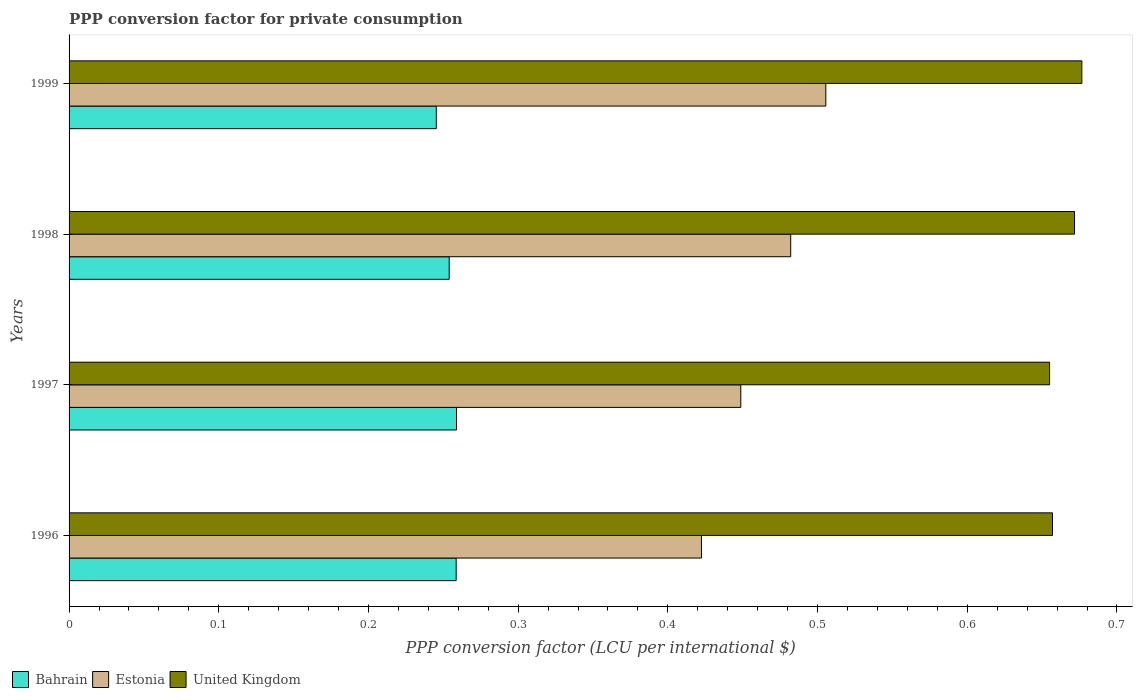How many different coloured bars are there?
Provide a succinct answer. 3. How many groups of bars are there?
Your response must be concise. 4. Are the number of bars per tick equal to the number of legend labels?
Make the answer very short. Yes. Are the number of bars on each tick of the Y-axis equal?
Offer a terse response. Yes. How many bars are there on the 2nd tick from the bottom?
Keep it short and to the point. 3. What is the PPP conversion factor for private consumption in United Kingdom in 1998?
Ensure brevity in your answer.  0.67. Across all years, what is the maximum PPP conversion factor for private consumption in United Kingdom?
Keep it short and to the point. 0.68. Across all years, what is the minimum PPP conversion factor for private consumption in Bahrain?
Provide a succinct answer. 0.25. In which year was the PPP conversion factor for private consumption in United Kingdom minimum?
Make the answer very short. 1997. What is the total PPP conversion factor for private consumption in United Kingdom in the graph?
Provide a short and direct response. 2.66. What is the difference between the PPP conversion factor for private consumption in United Kingdom in 1996 and that in 1999?
Make the answer very short. -0.02. What is the difference between the PPP conversion factor for private consumption in Estonia in 1996 and the PPP conversion factor for private consumption in United Kingdom in 1998?
Your response must be concise. -0.25. What is the average PPP conversion factor for private consumption in Estonia per year?
Your answer should be very brief. 0.46. In the year 1997, what is the difference between the PPP conversion factor for private consumption in Estonia and PPP conversion factor for private consumption in United Kingdom?
Your response must be concise. -0.21. In how many years, is the PPP conversion factor for private consumption in Estonia greater than 0.6000000000000001 LCU?
Offer a terse response. 0. What is the ratio of the PPP conversion factor for private consumption in Estonia in 1996 to that in 1999?
Your answer should be very brief. 0.84. Is the PPP conversion factor for private consumption in Bahrain in 1998 less than that in 1999?
Provide a short and direct response. No. What is the difference between the highest and the second highest PPP conversion factor for private consumption in Bahrain?
Your answer should be compact. 0. What is the difference between the highest and the lowest PPP conversion factor for private consumption in United Kingdom?
Your answer should be compact. 0.02. In how many years, is the PPP conversion factor for private consumption in Bahrain greater than the average PPP conversion factor for private consumption in Bahrain taken over all years?
Provide a succinct answer. 2. What does the 2nd bar from the top in 1996 represents?
Offer a terse response. Estonia. What does the 3rd bar from the bottom in 1999 represents?
Provide a succinct answer. United Kingdom. Is it the case that in every year, the sum of the PPP conversion factor for private consumption in Bahrain and PPP conversion factor for private consumption in Estonia is greater than the PPP conversion factor for private consumption in United Kingdom?
Offer a very short reply. Yes. How many bars are there?
Give a very brief answer. 12. How many years are there in the graph?
Provide a succinct answer. 4. What is the difference between two consecutive major ticks on the X-axis?
Your answer should be very brief. 0.1. Are the values on the major ticks of X-axis written in scientific E-notation?
Ensure brevity in your answer.  No. Does the graph contain any zero values?
Make the answer very short. No. Where does the legend appear in the graph?
Give a very brief answer. Bottom left. How are the legend labels stacked?
Keep it short and to the point. Horizontal. What is the title of the graph?
Your response must be concise. PPP conversion factor for private consumption. What is the label or title of the X-axis?
Your answer should be compact. PPP conversion factor (LCU per international $). What is the PPP conversion factor (LCU per international $) of Bahrain in 1996?
Your answer should be very brief. 0.26. What is the PPP conversion factor (LCU per international $) of Estonia in 1996?
Your answer should be compact. 0.42. What is the PPP conversion factor (LCU per international $) of United Kingdom in 1996?
Offer a terse response. 0.66. What is the PPP conversion factor (LCU per international $) of Bahrain in 1997?
Offer a terse response. 0.26. What is the PPP conversion factor (LCU per international $) in Estonia in 1997?
Keep it short and to the point. 0.45. What is the PPP conversion factor (LCU per international $) in United Kingdom in 1997?
Make the answer very short. 0.65. What is the PPP conversion factor (LCU per international $) of Bahrain in 1998?
Your answer should be very brief. 0.25. What is the PPP conversion factor (LCU per international $) in Estonia in 1998?
Keep it short and to the point. 0.48. What is the PPP conversion factor (LCU per international $) of United Kingdom in 1998?
Provide a succinct answer. 0.67. What is the PPP conversion factor (LCU per international $) of Bahrain in 1999?
Make the answer very short. 0.25. What is the PPP conversion factor (LCU per international $) of Estonia in 1999?
Provide a short and direct response. 0.51. What is the PPP conversion factor (LCU per international $) of United Kingdom in 1999?
Provide a short and direct response. 0.68. Across all years, what is the maximum PPP conversion factor (LCU per international $) in Bahrain?
Keep it short and to the point. 0.26. Across all years, what is the maximum PPP conversion factor (LCU per international $) of Estonia?
Your answer should be very brief. 0.51. Across all years, what is the maximum PPP conversion factor (LCU per international $) in United Kingdom?
Offer a terse response. 0.68. Across all years, what is the minimum PPP conversion factor (LCU per international $) of Bahrain?
Keep it short and to the point. 0.25. Across all years, what is the minimum PPP conversion factor (LCU per international $) in Estonia?
Provide a succinct answer. 0.42. Across all years, what is the minimum PPP conversion factor (LCU per international $) in United Kingdom?
Provide a short and direct response. 0.65. What is the total PPP conversion factor (LCU per international $) in Bahrain in the graph?
Offer a terse response. 1.02. What is the total PPP conversion factor (LCU per international $) of Estonia in the graph?
Your answer should be compact. 1.86. What is the total PPP conversion factor (LCU per international $) of United Kingdom in the graph?
Provide a succinct answer. 2.66. What is the difference between the PPP conversion factor (LCU per international $) of Bahrain in 1996 and that in 1997?
Your response must be concise. -0. What is the difference between the PPP conversion factor (LCU per international $) of Estonia in 1996 and that in 1997?
Give a very brief answer. -0.03. What is the difference between the PPP conversion factor (LCU per international $) of United Kingdom in 1996 and that in 1997?
Provide a short and direct response. 0. What is the difference between the PPP conversion factor (LCU per international $) in Bahrain in 1996 and that in 1998?
Make the answer very short. 0. What is the difference between the PPP conversion factor (LCU per international $) of Estonia in 1996 and that in 1998?
Ensure brevity in your answer.  -0.06. What is the difference between the PPP conversion factor (LCU per international $) in United Kingdom in 1996 and that in 1998?
Offer a terse response. -0.01. What is the difference between the PPP conversion factor (LCU per international $) in Bahrain in 1996 and that in 1999?
Keep it short and to the point. 0.01. What is the difference between the PPP conversion factor (LCU per international $) in Estonia in 1996 and that in 1999?
Provide a succinct answer. -0.08. What is the difference between the PPP conversion factor (LCU per international $) in United Kingdom in 1996 and that in 1999?
Ensure brevity in your answer.  -0.02. What is the difference between the PPP conversion factor (LCU per international $) in Bahrain in 1997 and that in 1998?
Offer a terse response. 0. What is the difference between the PPP conversion factor (LCU per international $) of Estonia in 1997 and that in 1998?
Your answer should be compact. -0.03. What is the difference between the PPP conversion factor (LCU per international $) in United Kingdom in 1997 and that in 1998?
Give a very brief answer. -0.02. What is the difference between the PPP conversion factor (LCU per international $) in Bahrain in 1997 and that in 1999?
Make the answer very short. 0.01. What is the difference between the PPP conversion factor (LCU per international $) of Estonia in 1997 and that in 1999?
Ensure brevity in your answer.  -0.06. What is the difference between the PPP conversion factor (LCU per international $) in United Kingdom in 1997 and that in 1999?
Provide a short and direct response. -0.02. What is the difference between the PPP conversion factor (LCU per international $) of Bahrain in 1998 and that in 1999?
Offer a terse response. 0.01. What is the difference between the PPP conversion factor (LCU per international $) of Estonia in 1998 and that in 1999?
Offer a terse response. -0.02. What is the difference between the PPP conversion factor (LCU per international $) of United Kingdom in 1998 and that in 1999?
Ensure brevity in your answer.  -0. What is the difference between the PPP conversion factor (LCU per international $) in Bahrain in 1996 and the PPP conversion factor (LCU per international $) in Estonia in 1997?
Keep it short and to the point. -0.19. What is the difference between the PPP conversion factor (LCU per international $) of Bahrain in 1996 and the PPP conversion factor (LCU per international $) of United Kingdom in 1997?
Offer a very short reply. -0.4. What is the difference between the PPP conversion factor (LCU per international $) in Estonia in 1996 and the PPP conversion factor (LCU per international $) in United Kingdom in 1997?
Keep it short and to the point. -0.23. What is the difference between the PPP conversion factor (LCU per international $) of Bahrain in 1996 and the PPP conversion factor (LCU per international $) of Estonia in 1998?
Give a very brief answer. -0.22. What is the difference between the PPP conversion factor (LCU per international $) of Bahrain in 1996 and the PPP conversion factor (LCU per international $) of United Kingdom in 1998?
Your answer should be compact. -0.41. What is the difference between the PPP conversion factor (LCU per international $) in Estonia in 1996 and the PPP conversion factor (LCU per international $) in United Kingdom in 1998?
Your answer should be compact. -0.25. What is the difference between the PPP conversion factor (LCU per international $) in Bahrain in 1996 and the PPP conversion factor (LCU per international $) in Estonia in 1999?
Make the answer very short. -0.25. What is the difference between the PPP conversion factor (LCU per international $) in Bahrain in 1996 and the PPP conversion factor (LCU per international $) in United Kingdom in 1999?
Give a very brief answer. -0.42. What is the difference between the PPP conversion factor (LCU per international $) in Estonia in 1996 and the PPP conversion factor (LCU per international $) in United Kingdom in 1999?
Your response must be concise. -0.25. What is the difference between the PPP conversion factor (LCU per international $) in Bahrain in 1997 and the PPP conversion factor (LCU per international $) in Estonia in 1998?
Make the answer very short. -0.22. What is the difference between the PPP conversion factor (LCU per international $) of Bahrain in 1997 and the PPP conversion factor (LCU per international $) of United Kingdom in 1998?
Keep it short and to the point. -0.41. What is the difference between the PPP conversion factor (LCU per international $) in Estonia in 1997 and the PPP conversion factor (LCU per international $) in United Kingdom in 1998?
Make the answer very short. -0.22. What is the difference between the PPP conversion factor (LCU per international $) of Bahrain in 1997 and the PPP conversion factor (LCU per international $) of Estonia in 1999?
Offer a terse response. -0.25. What is the difference between the PPP conversion factor (LCU per international $) in Bahrain in 1997 and the PPP conversion factor (LCU per international $) in United Kingdom in 1999?
Give a very brief answer. -0.42. What is the difference between the PPP conversion factor (LCU per international $) in Estonia in 1997 and the PPP conversion factor (LCU per international $) in United Kingdom in 1999?
Ensure brevity in your answer.  -0.23. What is the difference between the PPP conversion factor (LCU per international $) in Bahrain in 1998 and the PPP conversion factor (LCU per international $) in Estonia in 1999?
Offer a terse response. -0.25. What is the difference between the PPP conversion factor (LCU per international $) in Bahrain in 1998 and the PPP conversion factor (LCU per international $) in United Kingdom in 1999?
Keep it short and to the point. -0.42. What is the difference between the PPP conversion factor (LCU per international $) in Estonia in 1998 and the PPP conversion factor (LCU per international $) in United Kingdom in 1999?
Keep it short and to the point. -0.19. What is the average PPP conversion factor (LCU per international $) of Bahrain per year?
Keep it short and to the point. 0.25. What is the average PPP conversion factor (LCU per international $) of Estonia per year?
Keep it short and to the point. 0.46. What is the average PPP conversion factor (LCU per international $) in United Kingdom per year?
Offer a very short reply. 0.67. In the year 1996, what is the difference between the PPP conversion factor (LCU per international $) of Bahrain and PPP conversion factor (LCU per international $) of Estonia?
Your answer should be very brief. -0.16. In the year 1996, what is the difference between the PPP conversion factor (LCU per international $) of Bahrain and PPP conversion factor (LCU per international $) of United Kingdom?
Offer a very short reply. -0.4. In the year 1996, what is the difference between the PPP conversion factor (LCU per international $) of Estonia and PPP conversion factor (LCU per international $) of United Kingdom?
Ensure brevity in your answer.  -0.23. In the year 1997, what is the difference between the PPP conversion factor (LCU per international $) in Bahrain and PPP conversion factor (LCU per international $) in Estonia?
Make the answer very short. -0.19. In the year 1997, what is the difference between the PPP conversion factor (LCU per international $) of Bahrain and PPP conversion factor (LCU per international $) of United Kingdom?
Give a very brief answer. -0.4. In the year 1997, what is the difference between the PPP conversion factor (LCU per international $) in Estonia and PPP conversion factor (LCU per international $) in United Kingdom?
Provide a succinct answer. -0.21. In the year 1998, what is the difference between the PPP conversion factor (LCU per international $) in Bahrain and PPP conversion factor (LCU per international $) in Estonia?
Your answer should be very brief. -0.23. In the year 1998, what is the difference between the PPP conversion factor (LCU per international $) of Bahrain and PPP conversion factor (LCU per international $) of United Kingdom?
Provide a succinct answer. -0.42. In the year 1998, what is the difference between the PPP conversion factor (LCU per international $) in Estonia and PPP conversion factor (LCU per international $) in United Kingdom?
Provide a succinct answer. -0.19. In the year 1999, what is the difference between the PPP conversion factor (LCU per international $) of Bahrain and PPP conversion factor (LCU per international $) of Estonia?
Offer a terse response. -0.26. In the year 1999, what is the difference between the PPP conversion factor (LCU per international $) in Bahrain and PPP conversion factor (LCU per international $) in United Kingdom?
Your answer should be compact. -0.43. In the year 1999, what is the difference between the PPP conversion factor (LCU per international $) of Estonia and PPP conversion factor (LCU per international $) of United Kingdom?
Keep it short and to the point. -0.17. What is the ratio of the PPP conversion factor (LCU per international $) of Estonia in 1996 to that in 1997?
Make the answer very short. 0.94. What is the ratio of the PPP conversion factor (LCU per international $) in United Kingdom in 1996 to that in 1997?
Keep it short and to the point. 1. What is the ratio of the PPP conversion factor (LCU per international $) in Bahrain in 1996 to that in 1998?
Give a very brief answer. 1.02. What is the ratio of the PPP conversion factor (LCU per international $) of Estonia in 1996 to that in 1998?
Provide a succinct answer. 0.88. What is the ratio of the PPP conversion factor (LCU per international $) of United Kingdom in 1996 to that in 1998?
Your answer should be very brief. 0.98. What is the ratio of the PPP conversion factor (LCU per international $) of Bahrain in 1996 to that in 1999?
Your answer should be very brief. 1.05. What is the ratio of the PPP conversion factor (LCU per international $) in Estonia in 1996 to that in 1999?
Your response must be concise. 0.84. What is the ratio of the PPP conversion factor (LCU per international $) of Bahrain in 1997 to that in 1998?
Keep it short and to the point. 1.02. What is the ratio of the PPP conversion factor (LCU per international $) of Estonia in 1997 to that in 1998?
Your response must be concise. 0.93. What is the ratio of the PPP conversion factor (LCU per international $) of United Kingdom in 1997 to that in 1998?
Your answer should be very brief. 0.98. What is the ratio of the PPP conversion factor (LCU per international $) of Bahrain in 1997 to that in 1999?
Your answer should be very brief. 1.06. What is the ratio of the PPP conversion factor (LCU per international $) of Estonia in 1997 to that in 1999?
Keep it short and to the point. 0.89. What is the ratio of the PPP conversion factor (LCU per international $) of United Kingdom in 1997 to that in 1999?
Offer a terse response. 0.97. What is the ratio of the PPP conversion factor (LCU per international $) in Bahrain in 1998 to that in 1999?
Provide a succinct answer. 1.04. What is the ratio of the PPP conversion factor (LCU per international $) of Estonia in 1998 to that in 1999?
Ensure brevity in your answer.  0.95. What is the difference between the highest and the second highest PPP conversion factor (LCU per international $) of Bahrain?
Your answer should be very brief. 0. What is the difference between the highest and the second highest PPP conversion factor (LCU per international $) in Estonia?
Your answer should be very brief. 0.02. What is the difference between the highest and the second highest PPP conversion factor (LCU per international $) of United Kingdom?
Your answer should be compact. 0. What is the difference between the highest and the lowest PPP conversion factor (LCU per international $) of Bahrain?
Provide a short and direct response. 0.01. What is the difference between the highest and the lowest PPP conversion factor (LCU per international $) of Estonia?
Your answer should be very brief. 0.08. What is the difference between the highest and the lowest PPP conversion factor (LCU per international $) in United Kingdom?
Ensure brevity in your answer.  0.02. 